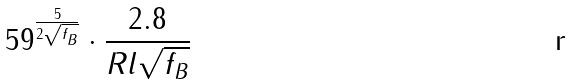<formula> <loc_0><loc_0><loc_500><loc_500>5 9 ^ { \frac { 5 } { 2 \sqrt { f _ { B } } } } \cdot \frac { 2 . 8 } { R l \sqrt { f _ { B } } }</formula> 